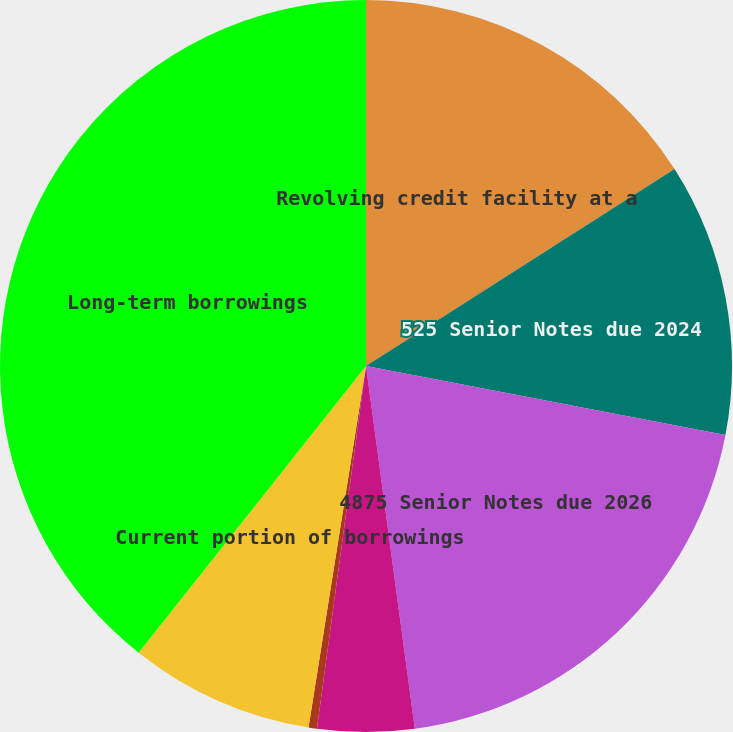Convert chart to OTSL. <chart><loc_0><loc_0><loc_500><loc_500><pie_chart><fcel>Revolving credit facility at a<fcel>525 Senior Notes due 2024<fcel>4875 Senior Notes due 2026<fcel>Securitization program at a<fcel>Less Unamortized debt issuance<fcel>Current portion of borrowings<fcel>Long-term borrowings<nl><fcel>15.96%<fcel>12.06%<fcel>19.85%<fcel>4.27%<fcel>0.37%<fcel>8.16%<fcel>39.33%<nl></chart> 